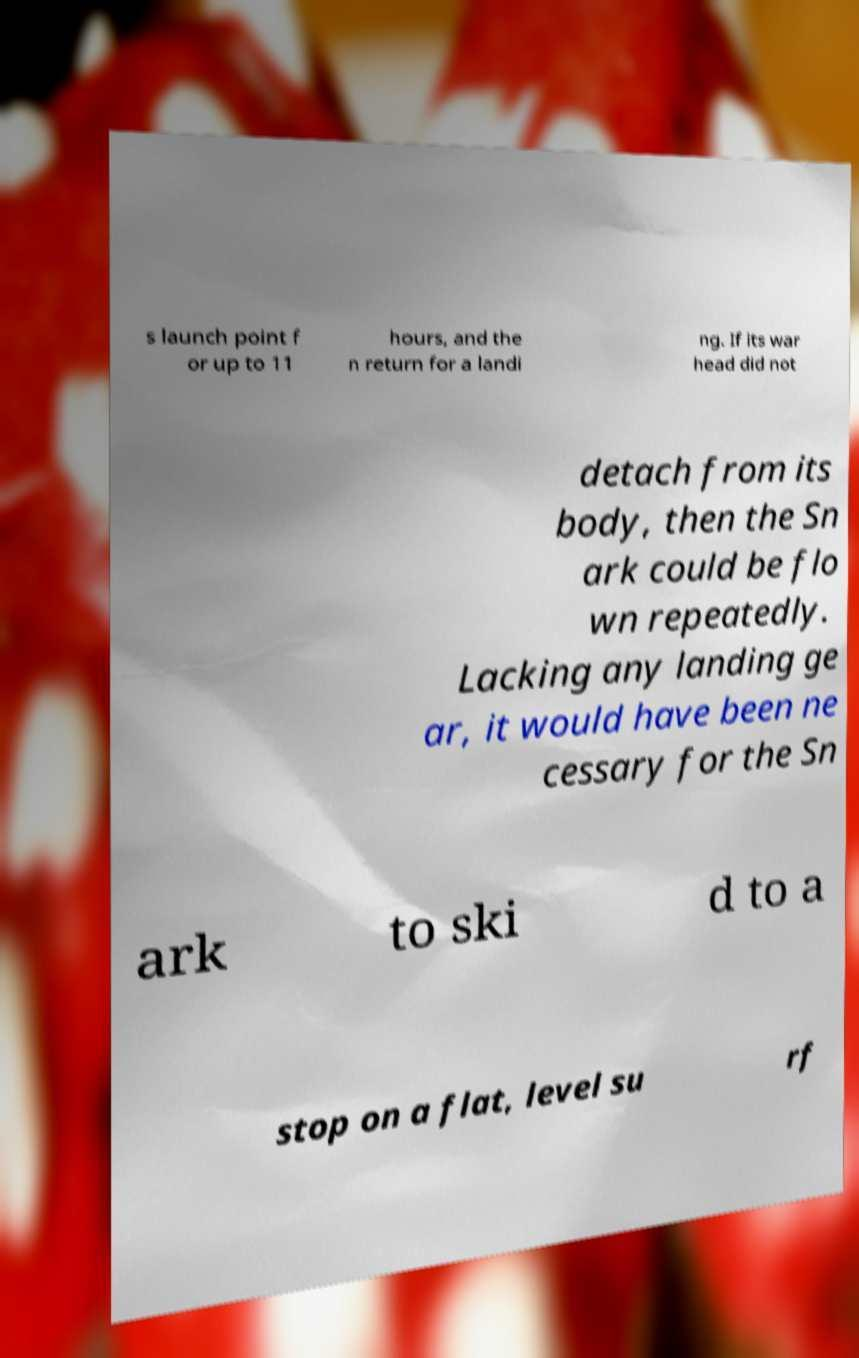Could you assist in decoding the text presented in this image and type it out clearly? s launch point f or up to 11 hours, and the n return for a landi ng. If its war head did not detach from its body, then the Sn ark could be flo wn repeatedly. Lacking any landing ge ar, it would have been ne cessary for the Sn ark to ski d to a stop on a flat, level su rf 